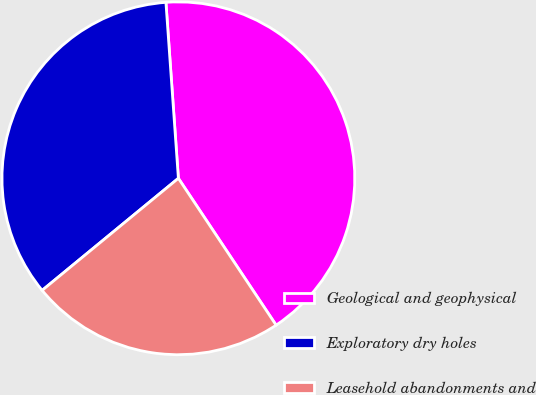<chart> <loc_0><loc_0><loc_500><loc_500><pie_chart><fcel>Geological and geophysical<fcel>Exploratory dry holes<fcel>Leasehold abandonments and<nl><fcel>41.78%<fcel>34.83%<fcel>23.39%<nl></chart> 